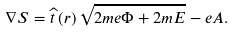Convert formula to latex. <formula><loc_0><loc_0><loc_500><loc_500>\nabla S = \widehat { t } \left ( { r } \right ) \sqrt { 2 m e \Phi + 2 m E } - e { A . }</formula> 